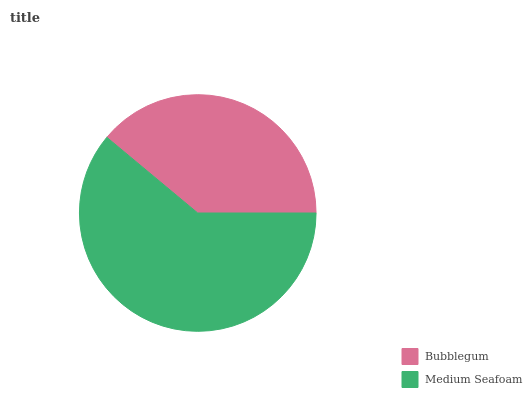Is Bubblegum the minimum?
Answer yes or no. Yes. Is Medium Seafoam the maximum?
Answer yes or no. Yes. Is Medium Seafoam the minimum?
Answer yes or no. No. Is Medium Seafoam greater than Bubblegum?
Answer yes or no. Yes. Is Bubblegum less than Medium Seafoam?
Answer yes or no. Yes. Is Bubblegum greater than Medium Seafoam?
Answer yes or no. No. Is Medium Seafoam less than Bubblegum?
Answer yes or no. No. Is Medium Seafoam the high median?
Answer yes or no. Yes. Is Bubblegum the low median?
Answer yes or no. Yes. Is Bubblegum the high median?
Answer yes or no. No. Is Medium Seafoam the low median?
Answer yes or no. No. 